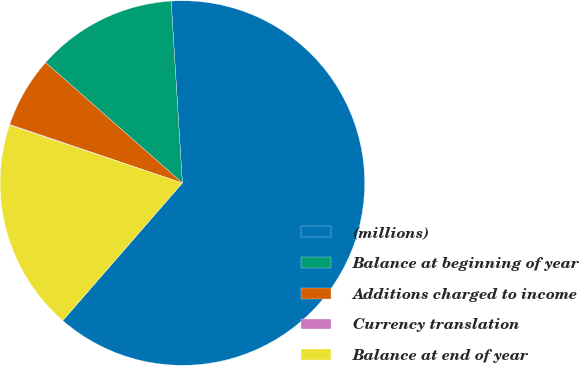Convert chart to OTSL. <chart><loc_0><loc_0><loc_500><loc_500><pie_chart><fcel>(millions)<fcel>Balance at beginning of year<fcel>Additions charged to income<fcel>Currency translation<fcel>Balance at end of year<nl><fcel>62.37%<fcel>12.52%<fcel>6.29%<fcel>0.06%<fcel>18.75%<nl></chart> 